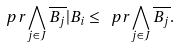<formula> <loc_0><loc_0><loc_500><loc_500>\ p r { \bigwedge _ { j \in J } \overline { B _ { j } } | B _ { i } } \leq \ p r { \bigwedge _ { j \in J } \overline { B _ { j } } } .</formula> 